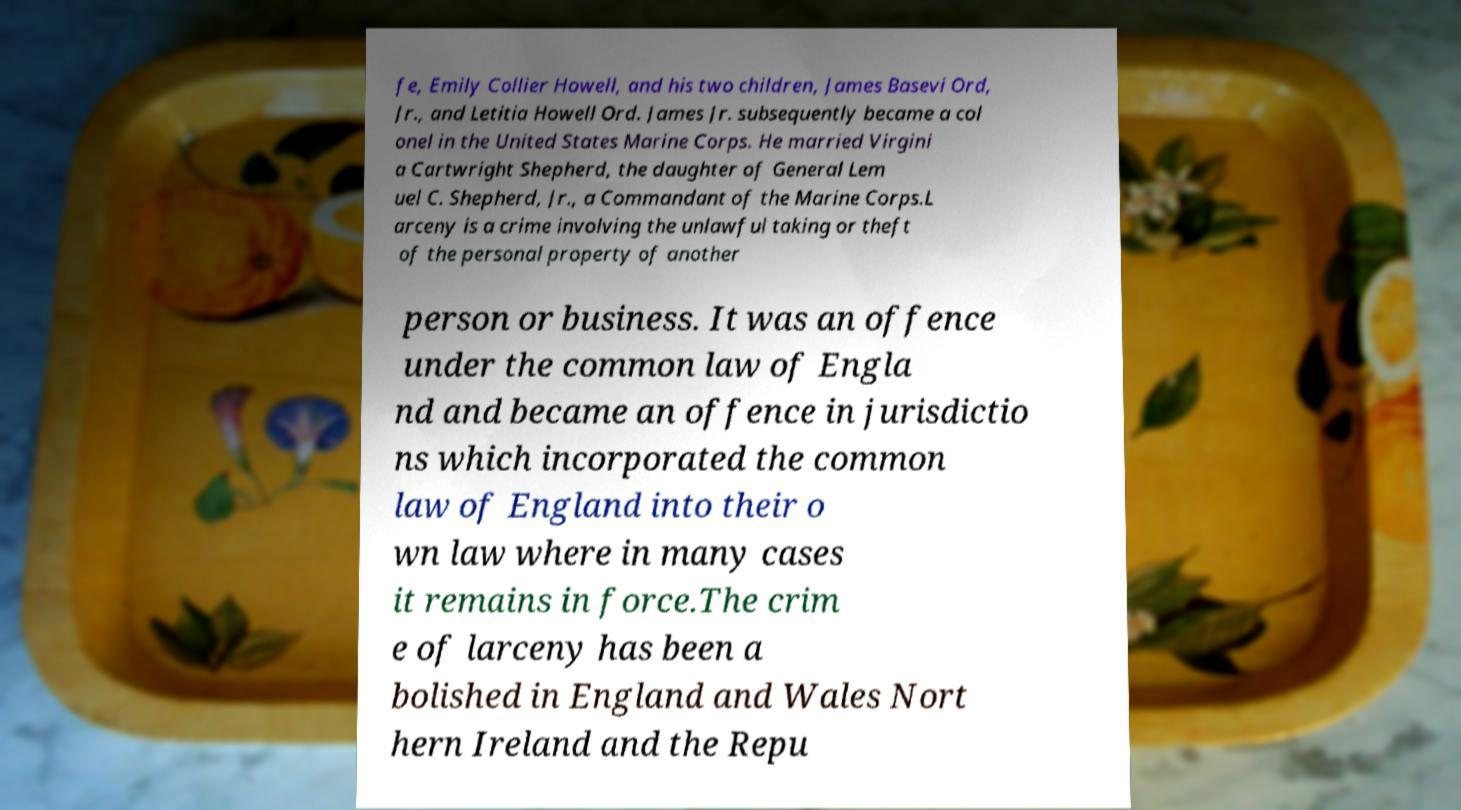Please read and relay the text visible in this image. What does it say? fe, Emily Collier Howell, and his two children, James Basevi Ord, Jr., and Letitia Howell Ord. James Jr. subsequently became a col onel in the United States Marine Corps. He married Virgini a Cartwright Shepherd, the daughter of General Lem uel C. Shepherd, Jr., a Commandant of the Marine Corps.L arceny is a crime involving the unlawful taking or theft of the personal property of another person or business. It was an offence under the common law of Engla nd and became an offence in jurisdictio ns which incorporated the common law of England into their o wn law where in many cases it remains in force.The crim e of larceny has been a bolished in England and Wales Nort hern Ireland and the Repu 